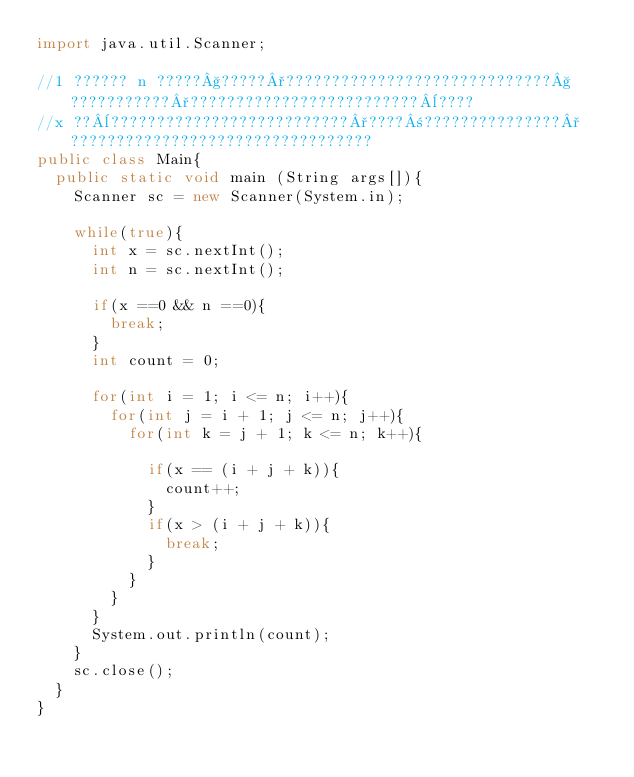Convert code to text. <code><loc_0><loc_0><loc_500><loc_500><_Java_>import java.util.Scanner;

//1 ?????? n ?????§?????°?????????????????????????????§???????????°?????????????????????????¨????
//x ??¨??????????????????????????°????±???????????????°?????????????????????????????????
public class Main{
	public static void main (String args[]){
		Scanner sc = new Scanner(System.in);

		while(true){
			int x = sc.nextInt();
			int n = sc.nextInt();

			if(x ==0 && n ==0){
				break;
			}
			int count = 0;

			for(int i = 1; i <= n; i++){
				for(int j = i + 1; j <= n; j++){
					for(int k = j + 1; k <= n; k++){

						if(x == (i + j + k)){
							count++;
						}
						if(x > (i + j + k)){
							break;
						}
					}
				}
			}
			System.out.println(count);
		}
		sc.close();
	}
}</code> 